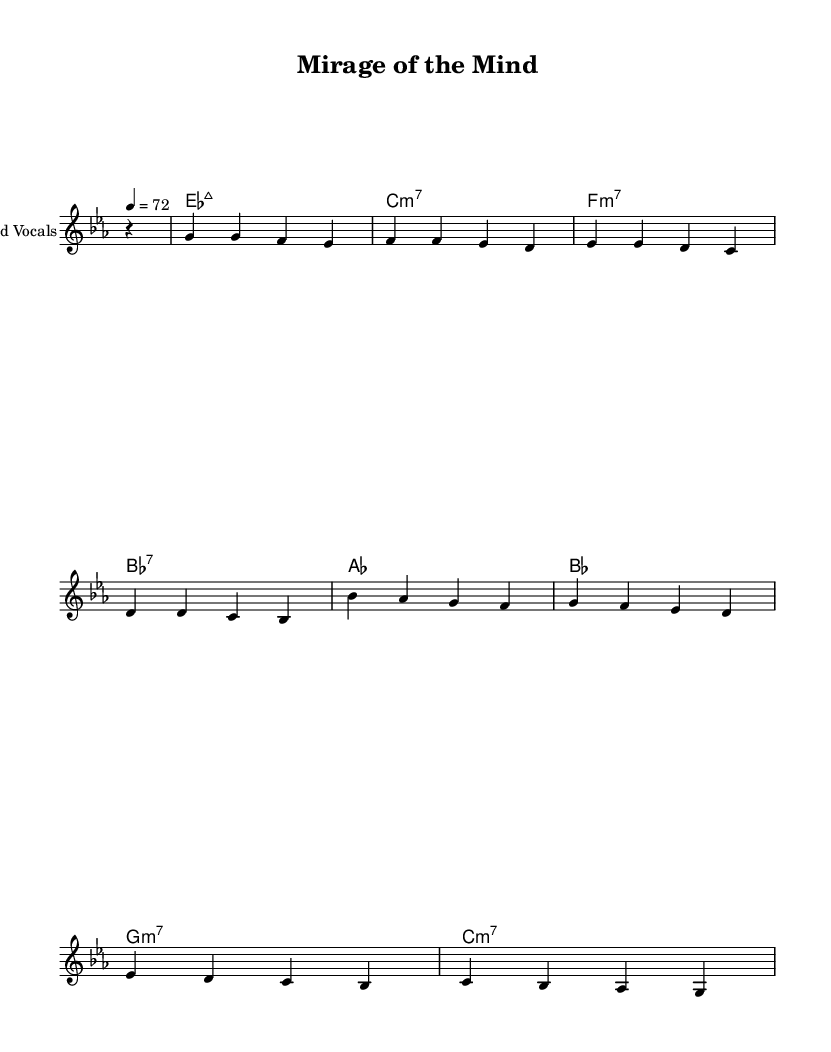What is the key signature of this music? The key signature is indicated at the beginning of the staff, showing two flats. This corresponds to the key of E-flat major.
Answer: E-flat major What is the time signature of this music? The time signature is found at the beginning of the sheet music, represented by a '4/4'. This means there are 4 beats in each measure and the quarter note receives one beat.
Answer: 4/4 What is the tempo of this piece? The tempo is indicated in the score, where it states '4 = 72', meaning that there are 72 quarter-note beats per minute.
Answer: 72 How many measures are in the melody? By counting the number of groups of notes separated by bar lines in the melody line, there are a total of 8 measures.
Answer: 8 What is the root of the first chord? The chord names are written above the melody line; the first chord is an E-flat major 7, the root note is E-flat.
Answer: E-flat Which chord is used before the last measure? Looking at the chords, the one before the last measure is a C minor 7 chord. This is revealed by examining the chord names listed sequentially.
Answer: C minor 7 What genre does this piece belong to? The piece is described in the context of smooth soul music, characterized by its melodic structure and harmony. The title also reflects the theme, which is linked to soul music.
Answer: Soul 